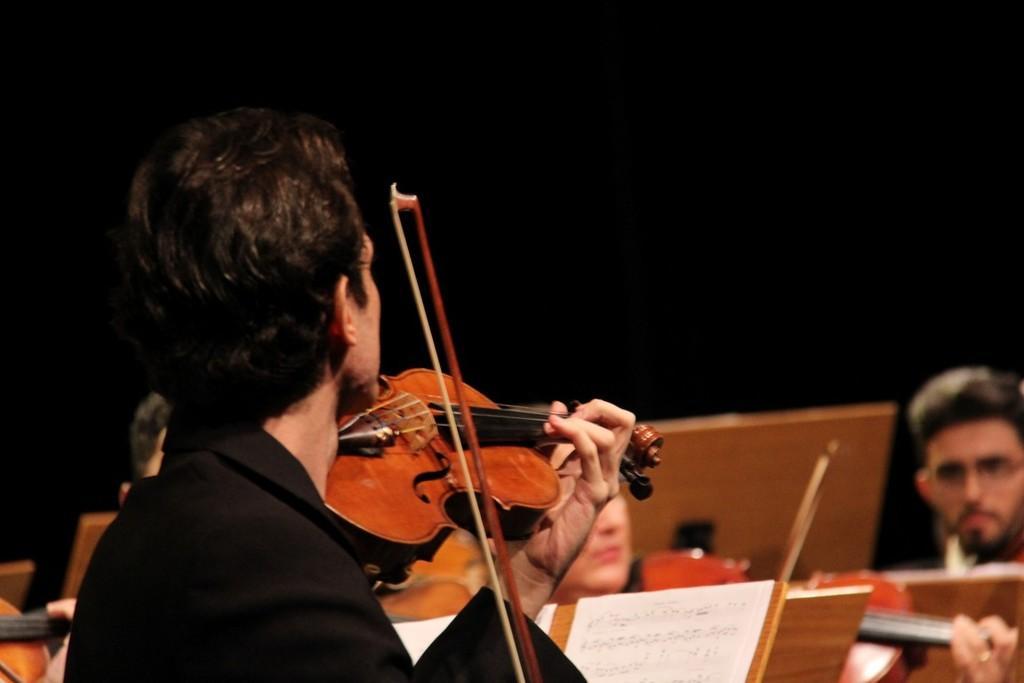In one or two sentences, can you explain what this image depicts? In this image, In the left side there is a man standing and holding a music instrument which is in yellow color, In the background there are some people sitting. 